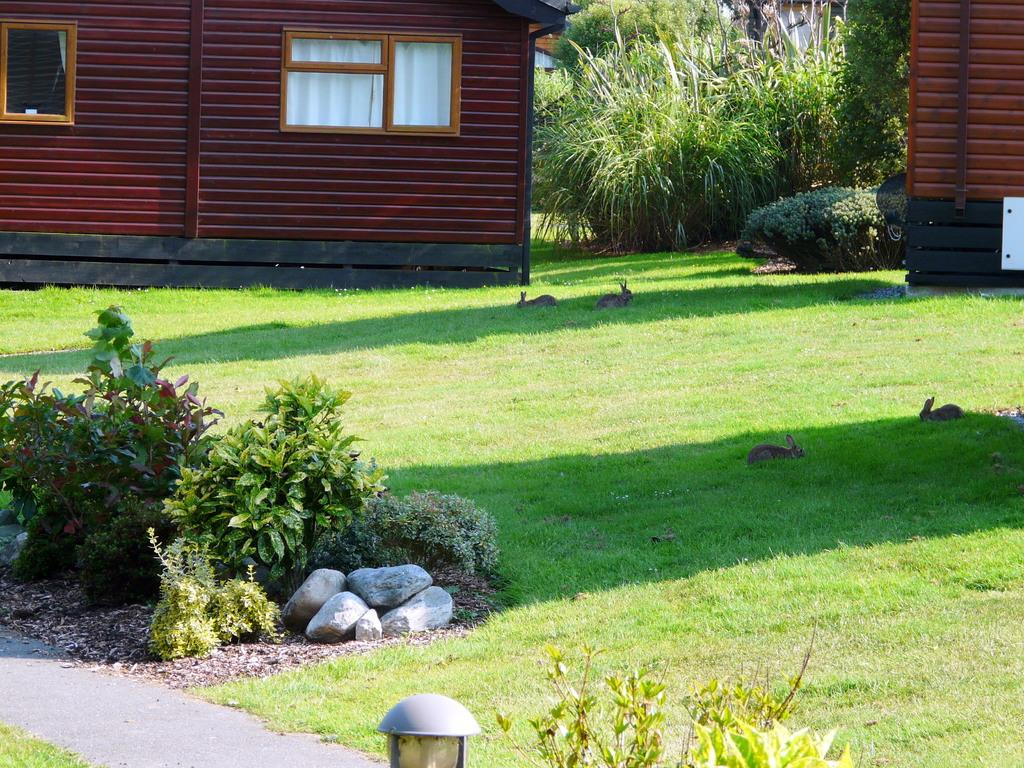What can be seen in the background of the image? There are houses and plants in the background of the image. What is present at the bottom of the image? There is grass, rabbits, plants, and small stones at the bottom of the image. Can you describe the lighting in the image? There is a light in the image. What type of quilt is being used to cover the rabbits in the image? There is no quilt present in the image; the rabbits are not covered. What color is the dress worn by the plants in the image? There are no plants wearing dresses in the image; plants do not wear clothing. 